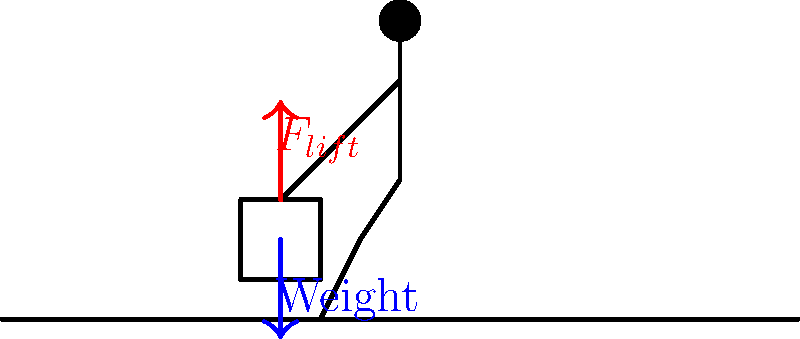When lifting a heavy object safely, which of the following statements about the force diagram is correct?

A) The lifting force should be equal to the weight of the object.
B) The lifting force should be applied at an angle to reduce strain.
C) The lifting force should be greater than the weight of the object.
D) The lifting force should be applied horizontally to minimize back stress. To understand the correct force diagram for safely lifting a heavy object, let's analyze the situation step-by-step:

1. Weight of the object: The object has a downward force due to gravity, represented by the blue arrow in the diagram.

2. Lifting force: To lift the object, an upward force must be applied, represented by the red arrow in the diagram.

3. Newton's Second Law: For the object to move upward, the net force must be positive in the upward direction. This means:

   $$F_{net} = F_{lift} - W > 0$$

   Where $F_{lift}$ is the lifting force and $W$ is the weight of the object.

4. Static equilibrium: If the object is to be held stationary after lifting, the net force must be zero:

   $$F_{net} = F_{lift} - W = 0$$
   $$F_{lift} = W$$

5. Initiation of movement: To start the lifting motion, the lifting force must overcome both the weight and the initial inertia of the object. This requires:

   $$F_{lift} > W$$

6. Direction of force: The safest way to lift is by applying the force vertically upward, keeping the object close to the body to minimize torque on the spine.

7. Angle considerations: Applying the force at an angle would introduce horizontal components, potentially causing instability and increasing the risk of injury.

Given these considerations, the correct statement is that the lifting force should be greater than the weight of the object, especially at the initiation of the lift. This ensures that the object can be lifted and accelerated upward safely.
Answer: C) The lifting force should be greater than the weight of the object. 